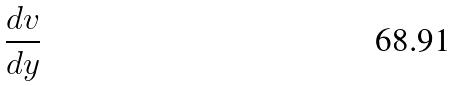<formula> <loc_0><loc_0><loc_500><loc_500>\frac { d v } { d y }</formula> 